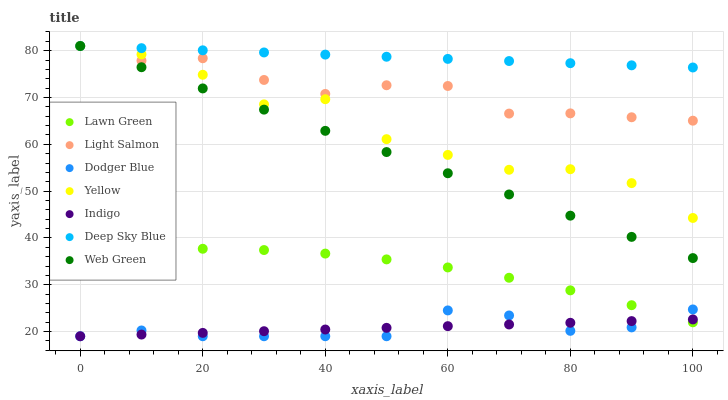Does Dodger Blue have the minimum area under the curve?
Answer yes or no. Yes. Does Deep Sky Blue have the maximum area under the curve?
Answer yes or no. Yes. Does Light Salmon have the minimum area under the curve?
Answer yes or no. No. Does Light Salmon have the maximum area under the curve?
Answer yes or no. No. Is Indigo the smoothest?
Answer yes or no. Yes. Is Yellow the roughest?
Answer yes or no. Yes. Is Light Salmon the smoothest?
Answer yes or no. No. Is Light Salmon the roughest?
Answer yes or no. No. Does Indigo have the lowest value?
Answer yes or no. Yes. Does Light Salmon have the lowest value?
Answer yes or no. No. Does Deep Sky Blue have the highest value?
Answer yes or no. Yes. Does Indigo have the highest value?
Answer yes or no. No. Is Indigo less than Web Green?
Answer yes or no. Yes. Is Yellow greater than Indigo?
Answer yes or no. Yes. Does Yellow intersect Deep Sky Blue?
Answer yes or no. Yes. Is Yellow less than Deep Sky Blue?
Answer yes or no. No. Is Yellow greater than Deep Sky Blue?
Answer yes or no. No. Does Indigo intersect Web Green?
Answer yes or no. No. 